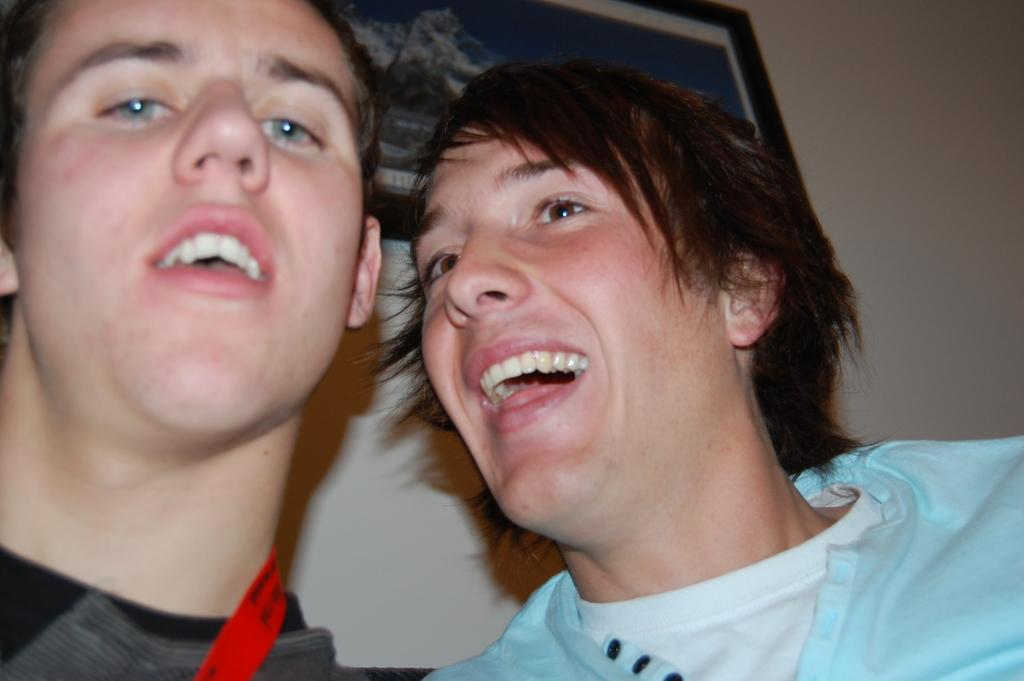Who is present in the image? There is a man and a person in the image. What is the man doing in the image? The man is looking to the left side. How is the person in the image reacting? The person is laughing. What color is the t-shirt worn by the person in the image? The person is wearing a light blue color t-shirt. What can be seen on the wall in the image? There is a frame on the wall in the image. What type of coil is being used by the father in the image? There is no father present in the image, and no coil is visible. Can you tell me how many docks are visible in the image? There are no docks present in the image. 